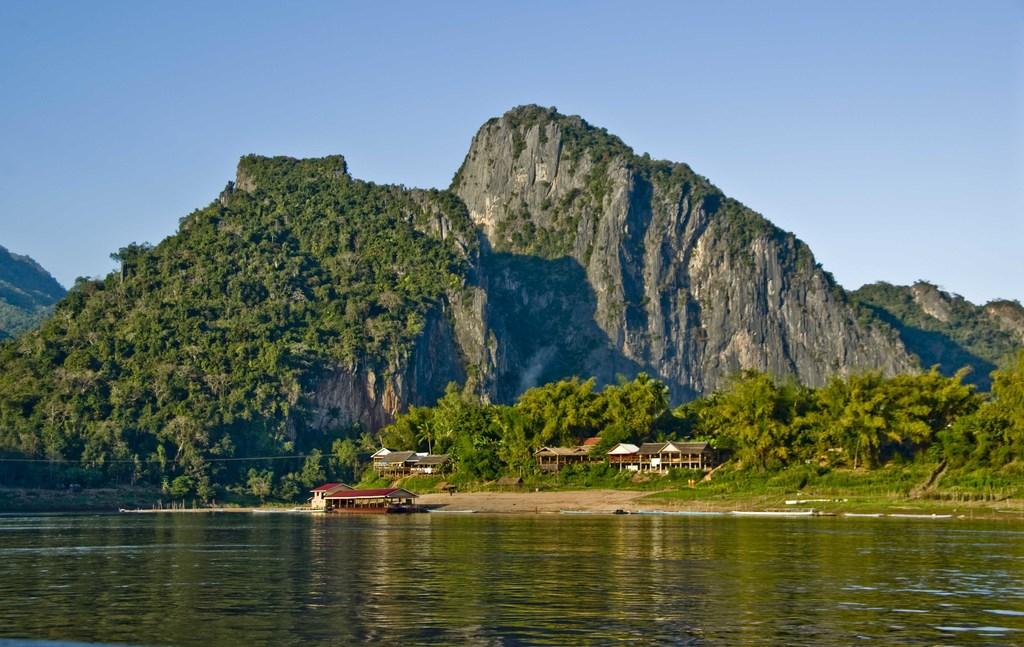What type of geographical feature is present in the image? There are mountains in the image. What covers the mountains in the image? The mountains are covered with trees. What is located at the bottom of the image? There is a river at the bottom of the image. What type of human-made structures can be seen in the image? There are houses in the image. How many trees are visible in the image? There are many trees in the image. What is visible at the top of the image? The sky is visible at the top of the image. What type of zephyr can be felt blowing through the trees in the image? There is no mention of a zephyr or any wind in the image, so it cannot be determined if one is present or what type it might be. 